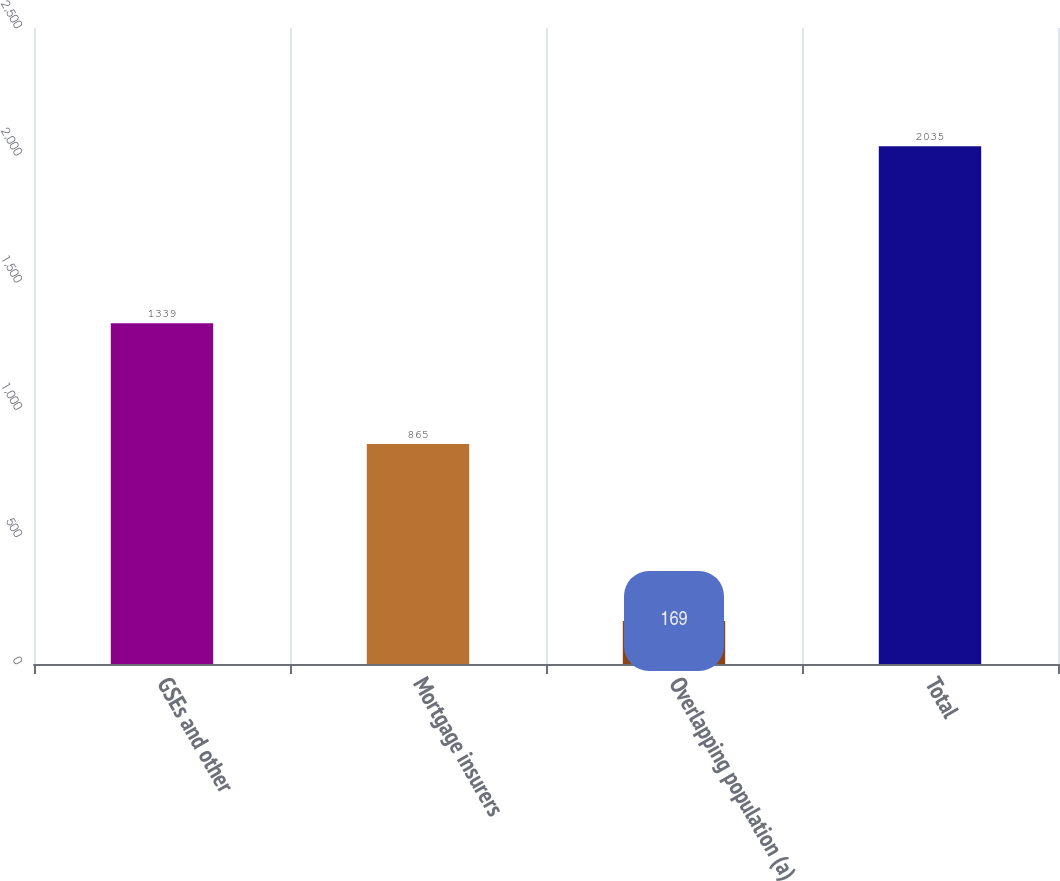Convert chart to OTSL. <chart><loc_0><loc_0><loc_500><loc_500><bar_chart><fcel>GSEs and other<fcel>Mortgage insurers<fcel>Overlapping population (a)<fcel>Total<nl><fcel>1339<fcel>865<fcel>169<fcel>2035<nl></chart> 